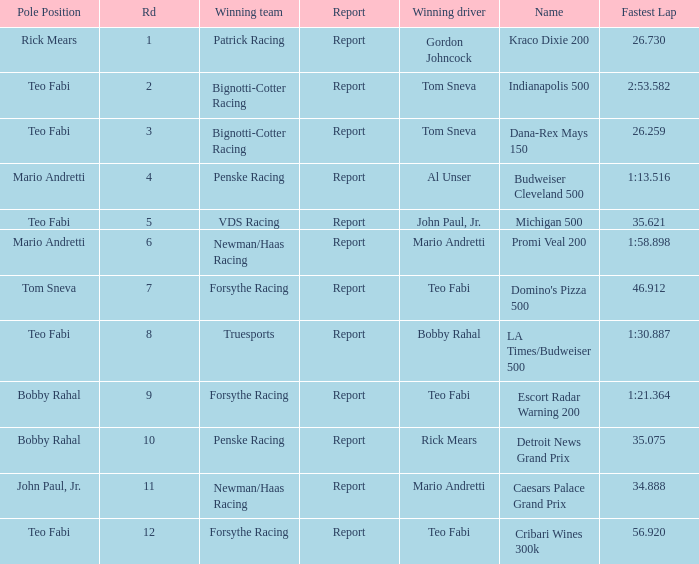What was the fastest lap time in the Escort Radar Warning 200? 1:21.364. 